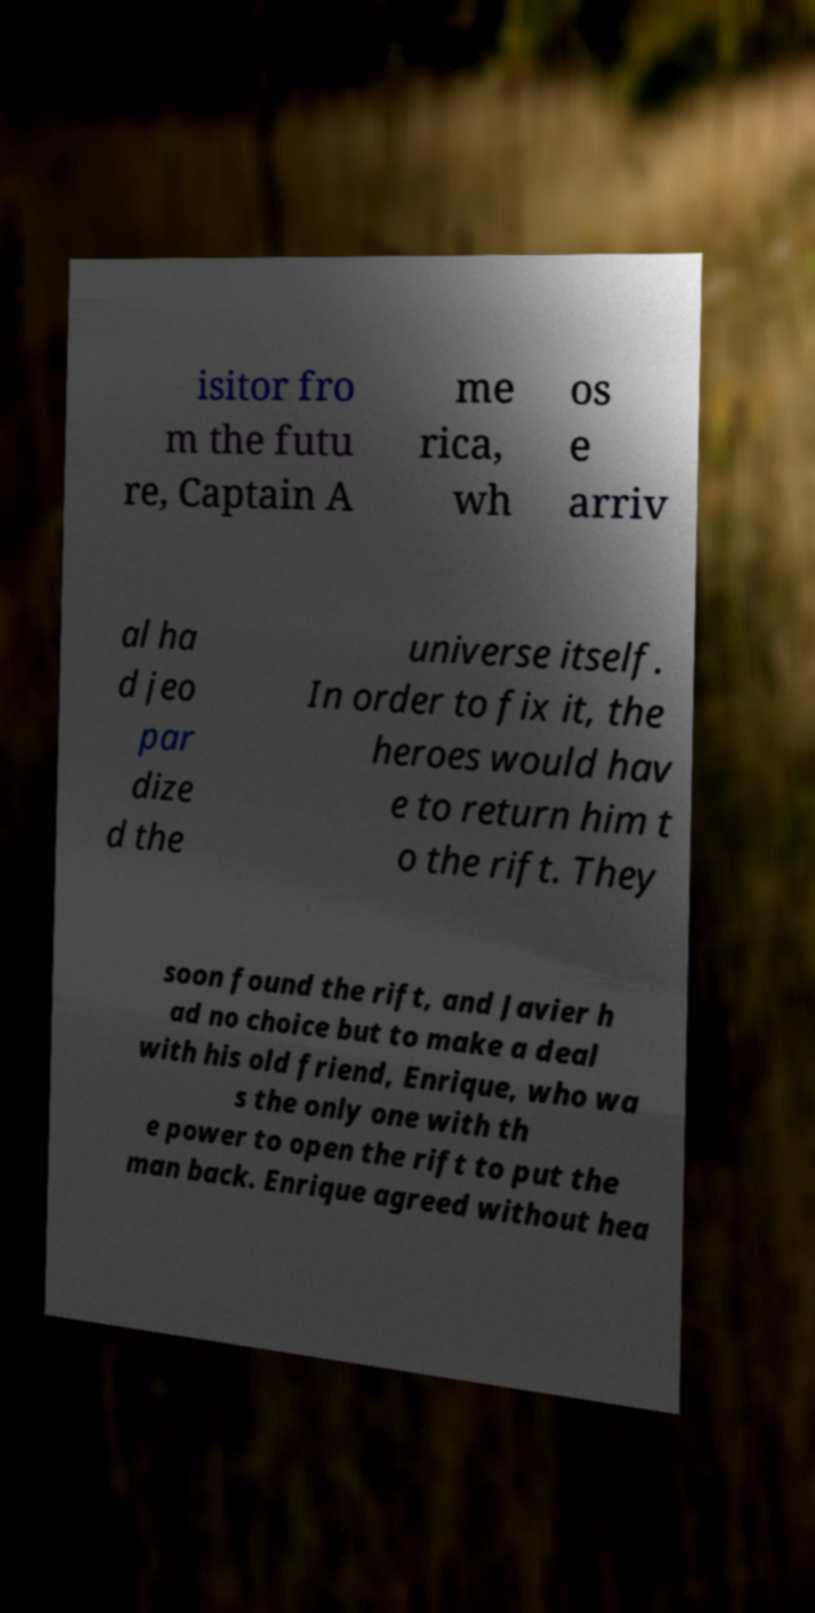Can you read and provide the text displayed in the image?This photo seems to have some interesting text. Can you extract and type it out for me? isitor fro m the futu re, Captain A me rica, wh os e arriv al ha d jeo par dize d the universe itself. In order to fix it, the heroes would hav e to return him t o the rift. They soon found the rift, and Javier h ad no choice but to make a deal with his old friend, Enrique, who wa s the only one with th e power to open the rift to put the man back. Enrique agreed without hea 